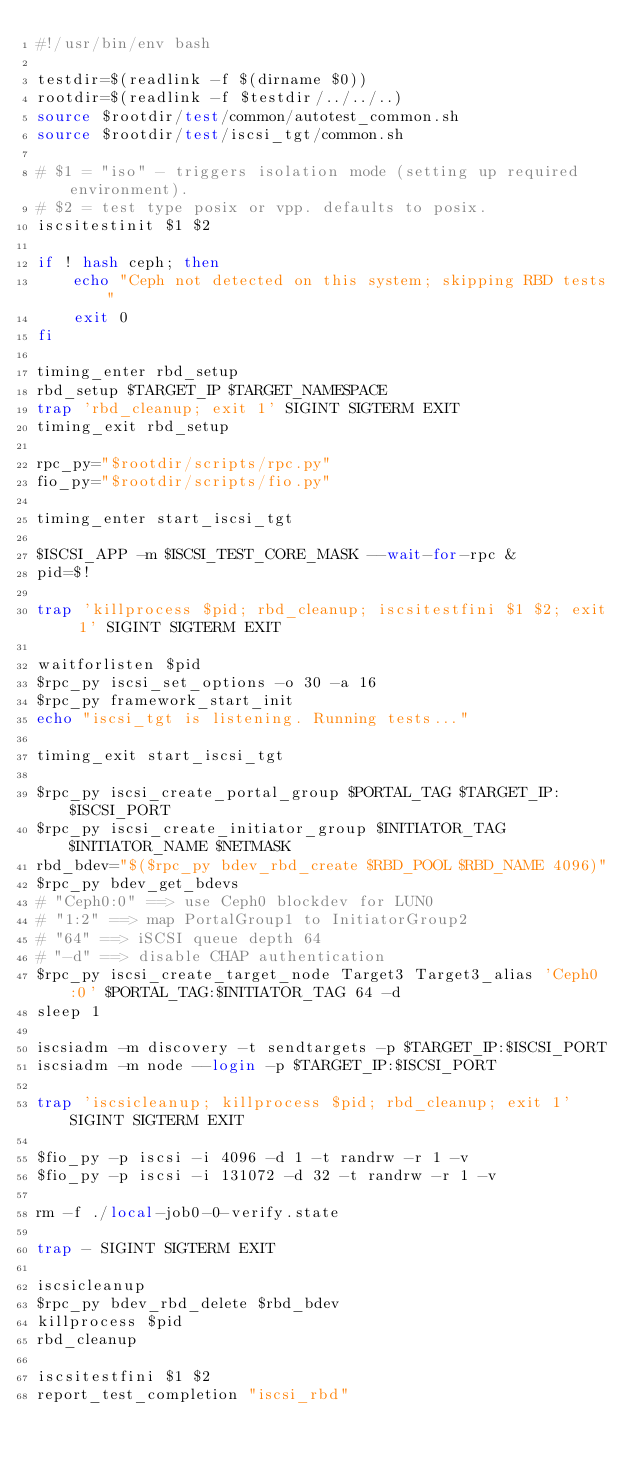<code> <loc_0><loc_0><loc_500><loc_500><_Bash_>#!/usr/bin/env bash

testdir=$(readlink -f $(dirname $0))
rootdir=$(readlink -f $testdir/../../..)
source $rootdir/test/common/autotest_common.sh
source $rootdir/test/iscsi_tgt/common.sh

# $1 = "iso" - triggers isolation mode (setting up required environment).
# $2 = test type posix or vpp. defaults to posix.
iscsitestinit $1 $2

if ! hash ceph; then
	echo "Ceph not detected on this system; skipping RBD tests"
	exit 0
fi

timing_enter rbd_setup
rbd_setup $TARGET_IP $TARGET_NAMESPACE
trap 'rbd_cleanup; exit 1' SIGINT SIGTERM EXIT
timing_exit rbd_setup

rpc_py="$rootdir/scripts/rpc.py"
fio_py="$rootdir/scripts/fio.py"

timing_enter start_iscsi_tgt

$ISCSI_APP -m $ISCSI_TEST_CORE_MASK --wait-for-rpc &
pid=$!

trap 'killprocess $pid; rbd_cleanup; iscsitestfini $1 $2; exit 1' SIGINT SIGTERM EXIT

waitforlisten $pid
$rpc_py iscsi_set_options -o 30 -a 16
$rpc_py framework_start_init
echo "iscsi_tgt is listening. Running tests..."

timing_exit start_iscsi_tgt

$rpc_py iscsi_create_portal_group $PORTAL_TAG $TARGET_IP:$ISCSI_PORT
$rpc_py iscsi_create_initiator_group $INITIATOR_TAG $INITIATOR_NAME $NETMASK
rbd_bdev="$($rpc_py bdev_rbd_create $RBD_POOL $RBD_NAME 4096)"
$rpc_py bdev_get_bdevs
# "Ceph0:0" ==> use Ceph0 blockdev for LUN0
# "1:2" ==> map PortalGroup1 to InitiatorGroup2
# "64" ==> iSCSI queue depth 64
# "-d" ==> disable CHAP authentication
$rpc_py iscsi_create_target_node Target3 Target3_alias 'Ceph0:0' $PORTAL_TAG:$INITIATOR_TAG 64 -d
sleep 1

iscsiadm -m discovery -t sendtargets -p $TARGET_IP:$ISCSI_PORT
iscsiadm -m node --login -p $TARGET_IP:$ISCSI_PORT

trap 'iscsicleanup; killprocess $pid; rbd_cleanup; exit 1' SIGINT SIGTERM EXIT

$fio_py -p iscsi -i 4096 -d 1 -t randrw -r 1 -v
$fio_py -p iscsi -i 131072 -d 32 -t randrw -r 1 -v

rm -f ./local-job0-0-verify.state

trap - SIGINT SIGTERM EXIT

iscsicleanup
$rpc_py bdev_rbd_delete $rbd_bdev
killprocess $pid
rbd_cleanup

iscsitestfini $1 $2
report_test_completion "iscsi_rbd"
</code> 